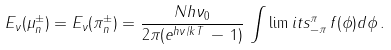<formula> <loc_0><loc_0><loc_500><loc_500>E _ { \nu } ( \mu ^ { \pm } _ { n } ) = E _ { \nu } ( \pi ^ { \pm } _ { n } ) = \frac { N h \nu _ { 0 } } { 2 \pi ( e ^ { h \nu / k T } \, - \, 1 ) } \, \int \lim i t s _ { - \pi } ^ { \pi } \, f ( \phi ) d \phi \, .</formula> 